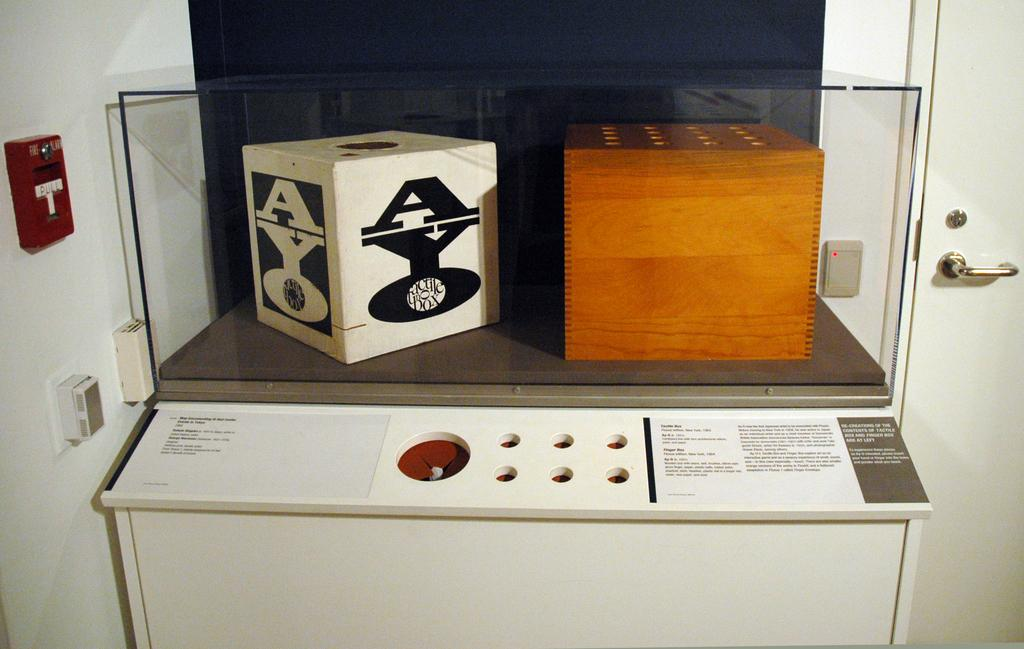<image>
Present a compact description of the photo's key features. a cube with the word 'ayo' on one side of it 